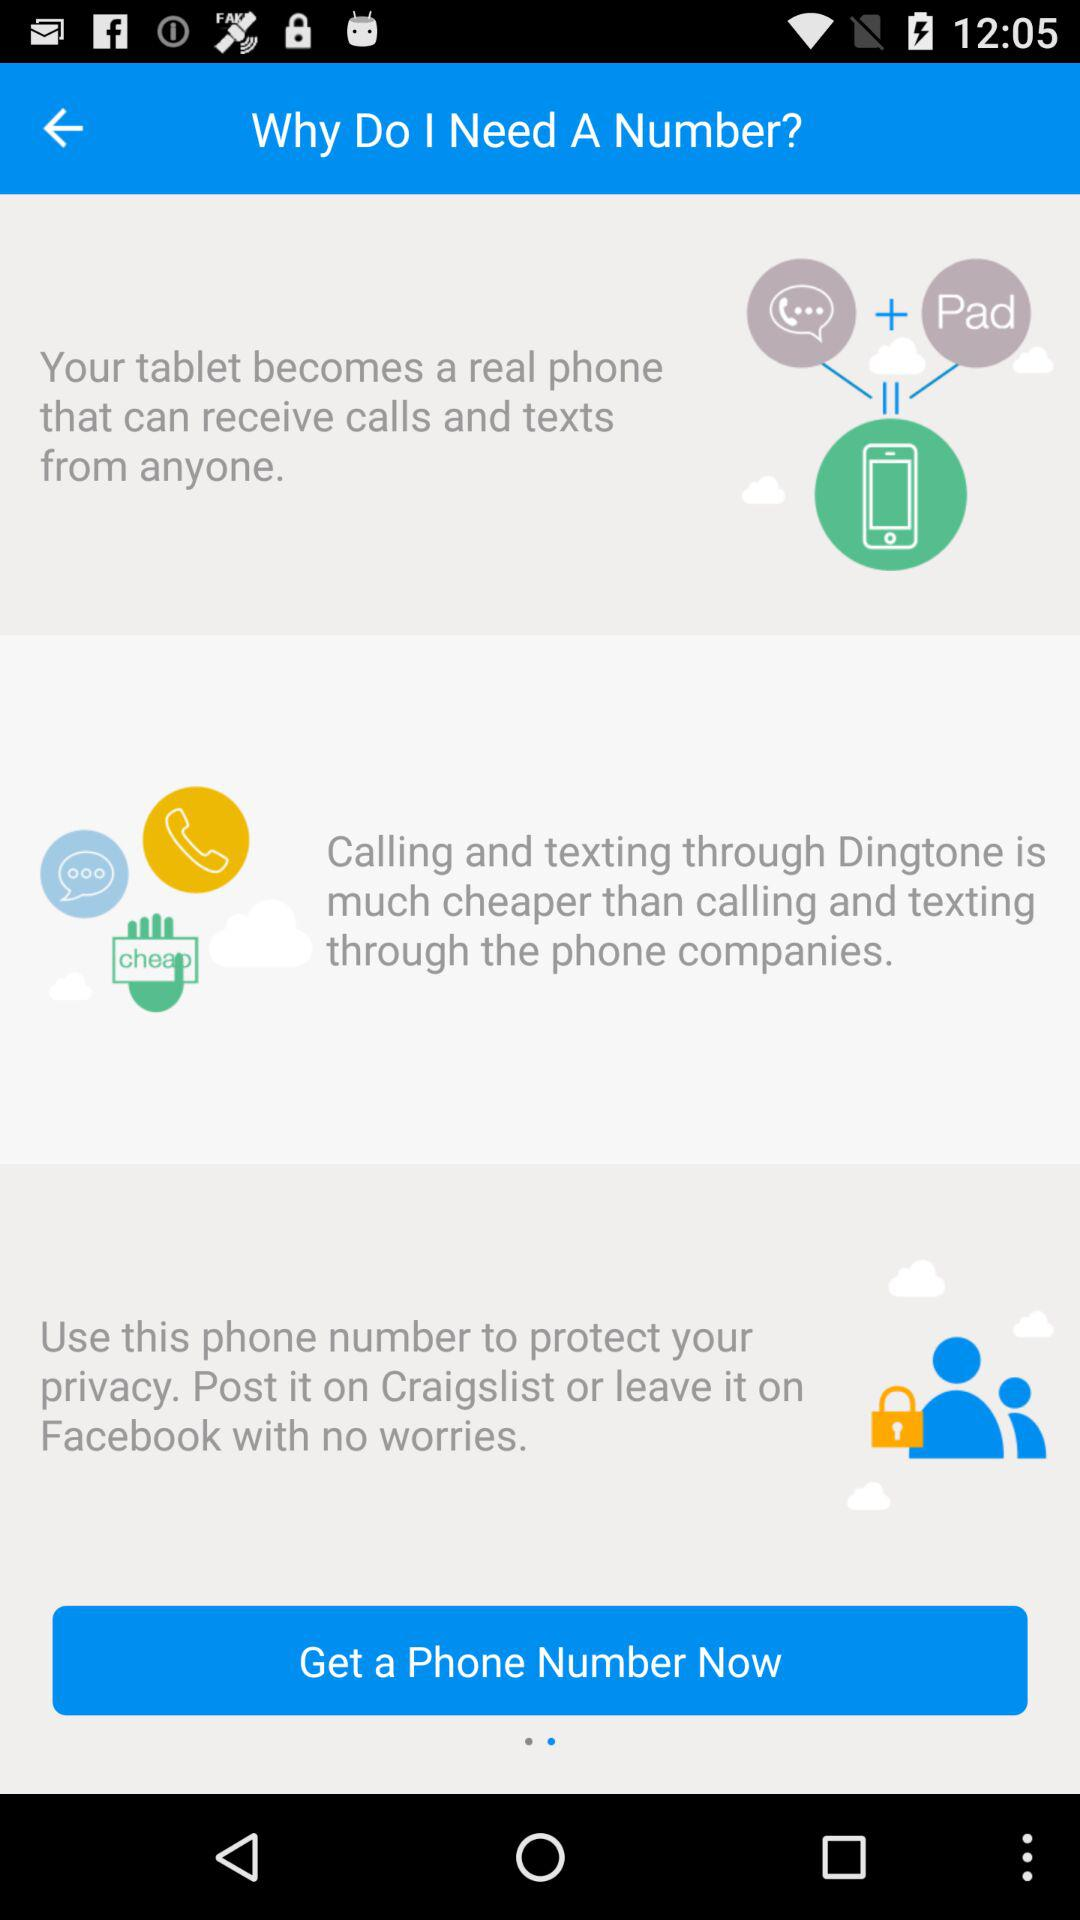What is Ding tone?
When the provided information is insufficient, respond with <no answer>. <no answer> 